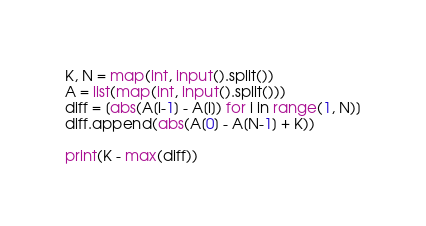<code> <loc_0><loc_0><loc_500><loc_500><_Python_>K, N = map(int, input().split())
A = list(map(int, input().split()))
diff = [abs(A[i-1] - A[i]) for i in range(1, N)]
diff.append(abs(A[0] - A[N-1] + K))

print(K - max(diff))</code> 